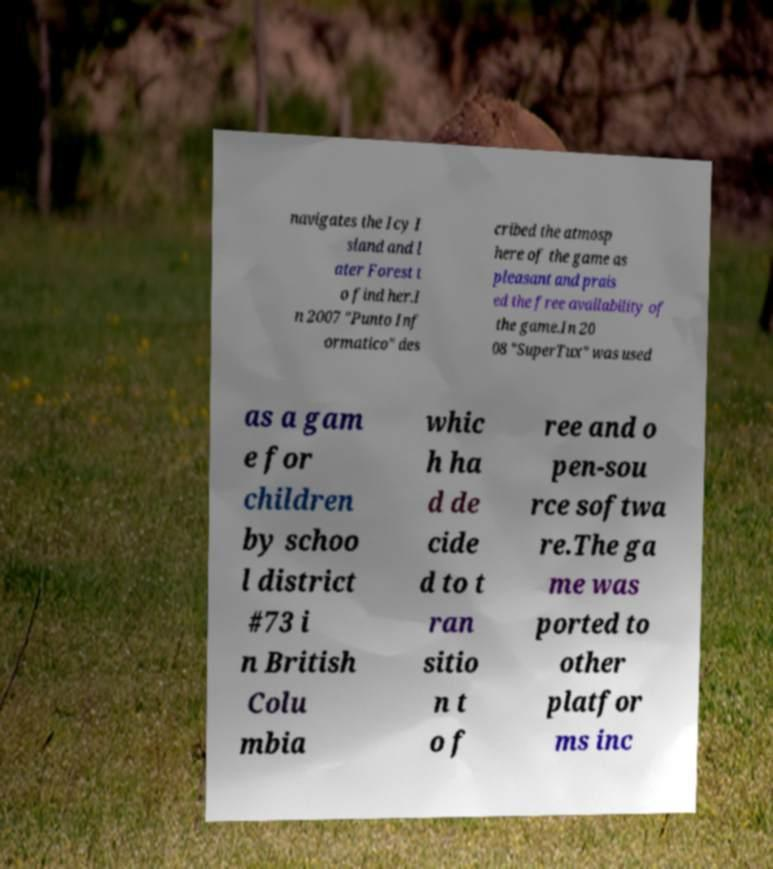There's text embedded in this image that I need extracted. Can you transcribe it verbatim? navigates the Icy I sland and l ater Forest t o find her.I n 2007 "Punto Inf ormatico" des cribed the atmosp here of the game as pleasant and prais ed the free availability of the game.In 20 08 "SuperTux" was used as a gam e for children by schoo l district #73 i n British Colu mbia whic h ha d de cide d to t ran sitio n t o f ree and o pen-sou rce softwa re.The ga me was ported to other platfor ms inc 